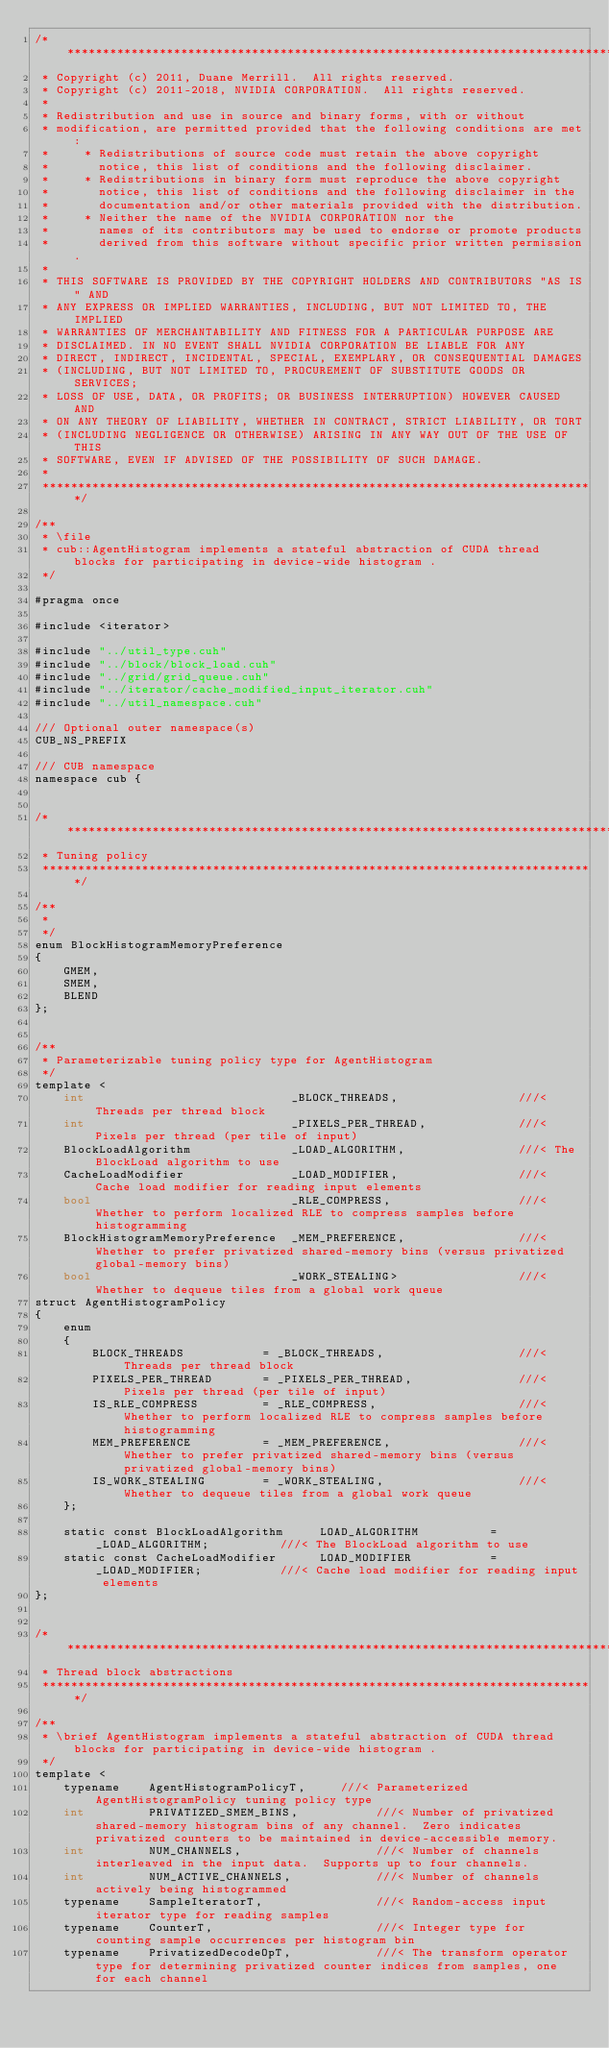<code> <loc_0><loc_0><loc_500><loc_500><_Cuda_>/******************************************************************************
 * Copyright (c) 2011, Duane Merrill.  All rights reserved.
 * Copyright (c) 2011-2018, NVIDIA CORPORATION.  All rights reserved.
 *
 * Redistribution and use in source and binary forms, with or without
 * modification, are permitted provided that the following conditions are met:
 *     * Redistributions of source code must retain the above copyright
 *       notice, this list of conditions and the following disclaimer.
 *     * Redistributions in binary form must reproduce the above copyright
 *       notice, this list of conditions and the following disclaimer in the
 *       documentation and/or other materials provided with the distribution.
 *     * Neither the name of the NVIDIA CORPORATION nor the
 *       names of its contributors may be used to endorse or promote products
 *       derived from this software without specific prior written permission.
 *
 * THIS SOFTWARE IS PROVIDED BY THE COPYRIGHT HOLDERS AND CONTRIBUTORS "AS IS" AND
 * ANY EXPRESS OR IMPLIED WARRANTIES, INCLUDING, BUT NOT LIMITED TO, THE IMPLIED
 * WARRANTIES OF MERCHANTABILITY AND FITNESS FOR A PARTICULAR PURPOSE ARE
 * DISCLAIMED. IN NO EVENT SHALL NVIDIA CORPORATION BE LIABLE FOR ANY
 * DIRECT, INDIRECT, INCIDENTAL, SPECIAL, EXEMPLARY, OR CONSEQUENTIAL DAMAGES
 * (INCLUDING, BUT NOT LIMITED TO, PROCUREMENT OF SUBSTITUTE GOODS OR SERVICES;
 * LOSS OF USE, DATA, OR PROFITS; OR BUSINESS INTERRUPTION) HOWEVER CAUSED AND
 * ON ANY THEORY OF LIABILITY, WHETHER IN CONTRACT, STRICT LIABILITY, OR TORT
 * (INCLUDING NEGLIGENCE OR OTHERWISE) ARISING IN ANY WAY OUT OF THE USE OF THIS
 * SOFTWARE, EVEN IF ADVISED OF THE POSSIBILITY OF SUCH DAMAGE.
 *
 ******************************************************************************/

/**
 * \file
 * cub::AgentHistogram implements a stateful abstraction of CUDA thread blocks for participating in device-wide histogram .
 */

#pragma once

#include <iterator>

#include "../util_type.cuh"
#include "../block/block_load.cuh"
#include "../grid/grid_queue.cuh"
#include "../iterator/cache_modified_input_iterator.cuh"
#include "../util_namespace.cuh"

/// Optional outer namespace(s)
CUB_NS_PREFIX

/// CUB namespace
namespace cub {


/******************************************************************************
 * Tuning policy
 ******************************************************************************/

/**
 *
 */
enum BlockHistogramMemoryPreference
{
    GMEM,
    SMEM,
    BLEND
};


/**
 * Parameterizable tuning policy type for AgentHistogram
 */
template <
    int                             _BLOCK_THREADS,                 ///< Threads per thread block
    int                             _PIXELS_PER_THREAD,             ///< Pixels per thread (per tile of input)
    BlockLoadAlgorithm              _LOAD_ALGORITHM,                ///< The BlockLoad algorithm to use
    CacheLoadModifier               _LOAD_MODIFIER,                 ///< Cache load modifier for reading input elements
    bool                            _RLE_COMPRESS,                  ///< Whether to perform localized RLE to compress samples before histogramming
    BlockHistogramMemoryPreference  _MEM_PREFERENCE,                ///< Whether to prefer privatized shared-memory bins (versus privatized global-memory bins)
    bool                            _WORK_STEALING>                 ///< Whether to dequeue tiles from a global work queue
struct AgentHistogramPolicy
{
    enum
    {
        BLOCK_THREADS           = _BLOCK_THREADS,                   ///< Threads per thread block
        PIXELS_PER_THREAD       = _PIXELS_PER_THREAD,               ///< Pixels per thread (per tile of input)
        IS_RLE_COMPRESS         = _RLE_COMPRESS,                    ///< Whether to perform localized RLE to compress samples before histogramming
        MEM_PREFERENCE          = _MEM_PREFERENCE,                  ///< Whether to prefer privatized shared-memory bins (versus privatized global-memory bins)
        IS_WORK_STEALING        = _WORK_STEALING,                   ///< Whether to dequeue tiles from a global work queue
    };

    static const BlockLoadAlgorithm     LOAD_ALGORITHM          = _LOAD_ALGORITHM;          ///< The BlockLoad algorithm to use
    static const CacheLoadModifier      LOAD_MODIFIER           = _LOAD_MODIFIER;           ///< Cache load modifier for reading input elements
};


/******************************************************************************
 * Thread block abstractions
 ******************************************************************************/

/**
 * \brief AgentHistogram implements a stateful abstraction of CUDA thread blocks for participating in device-wide histogram .
 */
template <
    typename    AgentHistogramPolicyT,     ///< Parameterized AgentHistogramPolicy tuning policy type
    int         PRIVATIZED_SMEM_BINS,           ///< Number of privatized shared-memory histogram bins of any channel.  Zero indicates privatized counters to be maintained in device-accessible memory.
    int         NUM_CHANNELS,                   ///< Number of channels interleaved in the input data.  Supports up to four channels.
    int         NUM_ACTIVE_CHANNELS,            ///< Number of channels actively being histogrammed
    typename    SampleIteratorT,                ///< Random-access input iterator type for reading samples
    typename    CounterT,                       ///< Integer type for counting sample occurrences per histogram bin
    typename    PrivatizedDecodeOpT,            ///< The transform operator type for determining privatized counter indices from samples, one for each channel</code> 